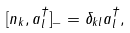<formula> <loc_0><loc_0><loc_500><loc_500>[ n _ { k } , a ^ { \dagger } _ { l } ] _ { - } = \delta _ { k l } a ^ { \dagger } _ { l } ,</formula> 